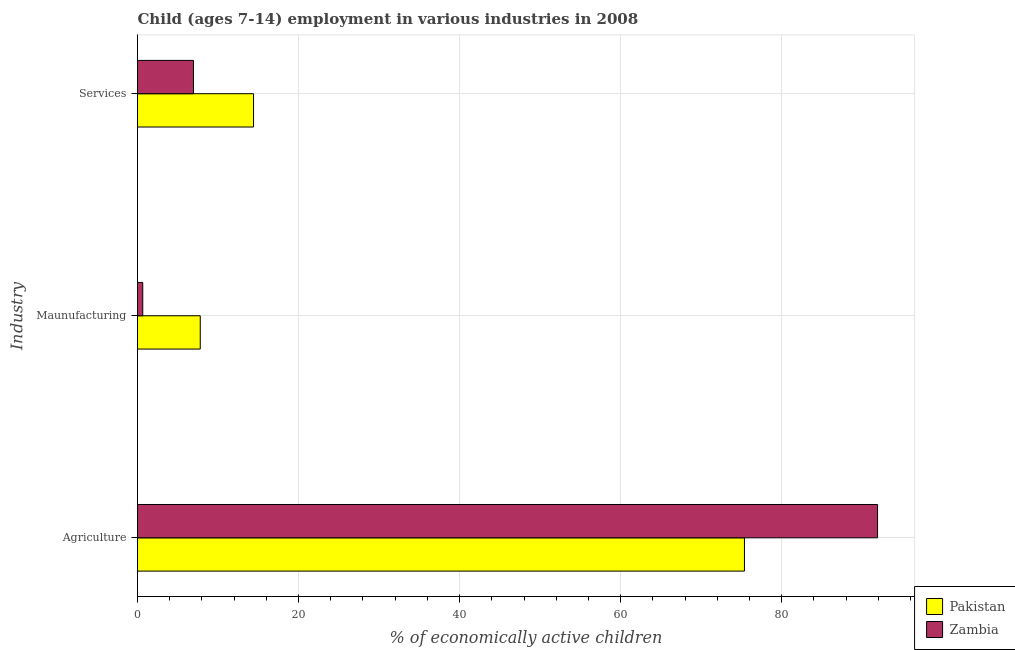How many different coloured bars are there?
Offer a very short reply. 2. How many groups of bars are there?
Keep it short and to the point. 3. Are the number of bars on each tick of the Y-axis equal?
Provide a short and direct response. Yes. How many bars are there on the 2nd tick from the bottom?
Provide a succinct answer. 2. What is the label of the 1st group of bars from the top?
Provide a succinct answer. Services. What is the percentage of economically active children in services in Zambia?
Provide a short and direct response. 6.95. Across all countries, what is the maximum percentage of economically active children in agriculture?
Provide a succinct answer. 91.9. Across all countries, what is the minimum percentage of economically active children in manufacturing?
Your answer should be compact. 0.65. In which country was the percentage of economically active children in agriculture maximum?
Provide a short and direct response. Zambia. In which country was the percentage of economically active children in manufacturing minimum?
Offer a very short reply. Zambia. What is the total percentage of economically active children in manufacturing in the graph?
Offer a very short reply. 8.44. What is the difference between the percentage of economically active children in manufacturing in Zambia and that in Pakistan?
Ensure brevity in your answer.  -7.14. What is the difference between the percentage of economically active children in agriculture in Zambia and the percentage of economically active children in services in Pakistan?
Provide a succinct answer. 77.49. What is the average percentage of economically active children in agriculture per country?
Make the answer very short. 83.64. What is the difference between the percentage of economically active children in manufacturing and percentage of economically active children in services in Pakistan?
Your answer should be compact. -6.62. In how many countries, is the percentage of economically active children in manufacturing greater than 56 %?
Make the answer very short. 0. What is the ratio of the percentage of economically active children in agriculture in Zambia to that in Pakistan?
Give a very brief answer. 1.22. Is the percentage of economically active children in agriculture in Zambia less than that in Pakistan?
Offer a terse response. No. Is the difference between the percentage of economically active children in manufacturing in Zambia and Pakistan greater than the difference between the percentage of economically active children in agriculture in Zambia and Pakistan?
Provide a short and direct response. No. What is the difference between the highest and the second highest percentage of economically active children in manufacturing?
Your answer should be very brief. 7.14. What is the difference between the highest and the lowest percentage of economically active children in services?
Make the answer very short. 7.46. Is the sum of the percentage of economically active children in manufacturing in Zambia and Pakistan greater than the maximum percentage of economically active children in agriculture across all countries?
Keep it short and to the point. No. Is it the case that in every country, the sum of the percentage of economically active children in agriculture and percentage of economically active children in manufacturing is greater than the percentage of economically active children in services?
Provide a succinct answer. Yes. How many bars are there?
Your response must be concise. 6. How many countries are there in the graph?
Provide a succinct answer. 2. What is the difference between two consecutive major ticks on the X-axis?
Offer a very short reply. 20. Are the values on the major ticks of X-axis written in scientific E-notation?
Offer a terse response. No. Does the graph contain any zero values?
Make the answer very short. No. Where does the legend appear in the graph?
Provide a short and direct response. Bottom right. How are the legend labels stacked?
Your answer should be very brief. Vertical. What is the title of the graph?
Provide a succinct answer. Child (ages 7-14) employment in various industries in 2008. Does "Bhutan" appear as one of the legend labels in the graph?
Offer a very short reply. No. What is the label or title of the X-axis?
Your response must be concise. % of economically active children. What is the label or title of the Y-axis?
Ensure brevity in your answer.  Industry. What is the % of economically active children of Pakistan in Agriculture?
Your answer should be very brief. 75.37. What is the % of economically active children of Zambia in Agriculture?
Your response must be concise. 91.9. What is the % of economically active children of Pakistan in Maunufacturing?
Provide a succinct answer. 7.79. What is the % of economically active children in Zambia in Maunufacturing?
Make the answer very short. 0.65. What is the % of economically active children in Pakistan in Services?
Offer a terse response. 14.41. What is the % of economically active children of Zambia in Services?
Give a very brief answer. 6.95. Across all Industry, what is the maximum % of economically active children of Pakistan?
Your response must be concise. 75.37. Across all Industry, what is the maximum % of economically active children in Zambia?
Your answer should be very brief. 91.9. Across all Industry, what is the minimum % of economically active children of Pakistan?
Offer a very short reply. 7.79. Across all Industry, what is the minimum % of economically active children in Zambia?
Give a very brief answer. 0.65. What is the total % of economically active children in Pakistan in the graph?
Your answer should be very brief. 97.57. What is the total % of economically active children in Zambia in the graph?
Make the answer very short. 99.5. What is the difference between the % of economically active children in Pakistan in Agriculture and that in Maunufacturing?
Keep it short and to the point. 67.58. What is the difference between the % of economically active children of Zambia in Agriculture and that in Maunufacturing?
Provide a succinct answer. 91.25. What is the difference between the % of economically active children in Pakistan in Agriculture and that in Services?
Keep it short and to the point. 60.96. What is the difference between the % of economically active children in Zambia in Agriculture and that in Services?
Ensure brevity in your answer.  84.95. What is the difference between the % of economically active children of Pakistan in Maunufacturing and that in Services?
Provide a succinct answer. -6.62. What is the difference between the % of economically active children of Pakistan in Agriculture and the % of economically active children of Zambia in Maunufacturing?
Your answer should be compact. 74.72. What is the difference between the % of economically active children in Pakistan in Agriculture and the % of economically active children in Zambia in Services?
Your answer should be very brief. 68.42. What is the difference between the % of economically active children in Pakistan in Maunufacturing and the % of economically active children in Zambia in Services?
Ensure brevity in your answer.  0.84. What is the average % of economically active children in Pakistan per Industry?
Give a very brief answer. 32.52. What is the average % of economically active children in Zambia per Industry?
Ensure brevity in your answer.  33.17. What is the difference between the % of economically active children in Pakistan and % of economically active children in Zambia in Agriculture?
Your answer should be very brief. -16.53. What is the difference between the % of economically active children of Pakistan and % of economically active children of Zambia in Maunufacturing?
Offer a very short reply. 7.14. What is the difference between the % of economically active children in Pakistan and % of economically active children in Zambia in Services?
Provide a succinct answer. 7.46. What is the ratio of the % of economically active children of Pakistan in Agriculture to that in Maunufacturing?
Ensure brevity in your answer.  9.68. What is the ratio of the % of economically active children of Zambia in Agriculture to that in Maunufacturing?
Ensure brevity in your answer.  141.38. What is the ratio of the % of economically active children of Pakistan in Agriculture to that in Services?
Provide a succinct answer. 5.23. What is the ratio of the % of economically active children in Zambia in Agriculture to that in Services?
Provide a short and direct response. 13.22. What is the ratio of the % of economically active children of Pakistan in Maunufacturing to that in Services?
Provide a succinct answer. 0.54. What is the ratio of the % of economically active children of Zambia in Maunufacturing to that in Services?
Your response must be concise. 0.09. What is the difference between the highest and the second highest % of economically active children of Pakistan?
Ensure brevity in your answer.  60.96. What is the difference between the highest and the second highest % of economically active children in Zambia?
Offer a terse response. 84.95. What is the difference between the highest and the lowest % of economically active children of Pakistan?
Give a very brief answer. 67.58. What is the difference between the highest and the lowest % of economically active children of Zambia?
Make the answer very short. 91.25. 